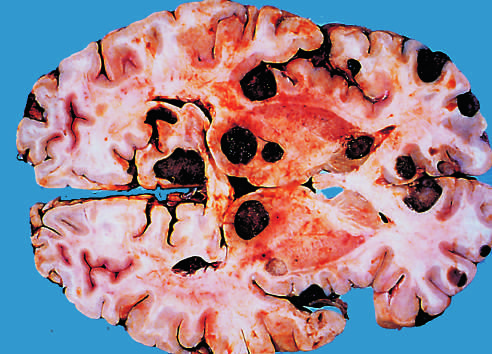what are distinguished grossly from most primary central nervous system tumors by their multicentricity and well-demarcated margins?
Answer the question using a single word or phrase. Metastatic lesions 